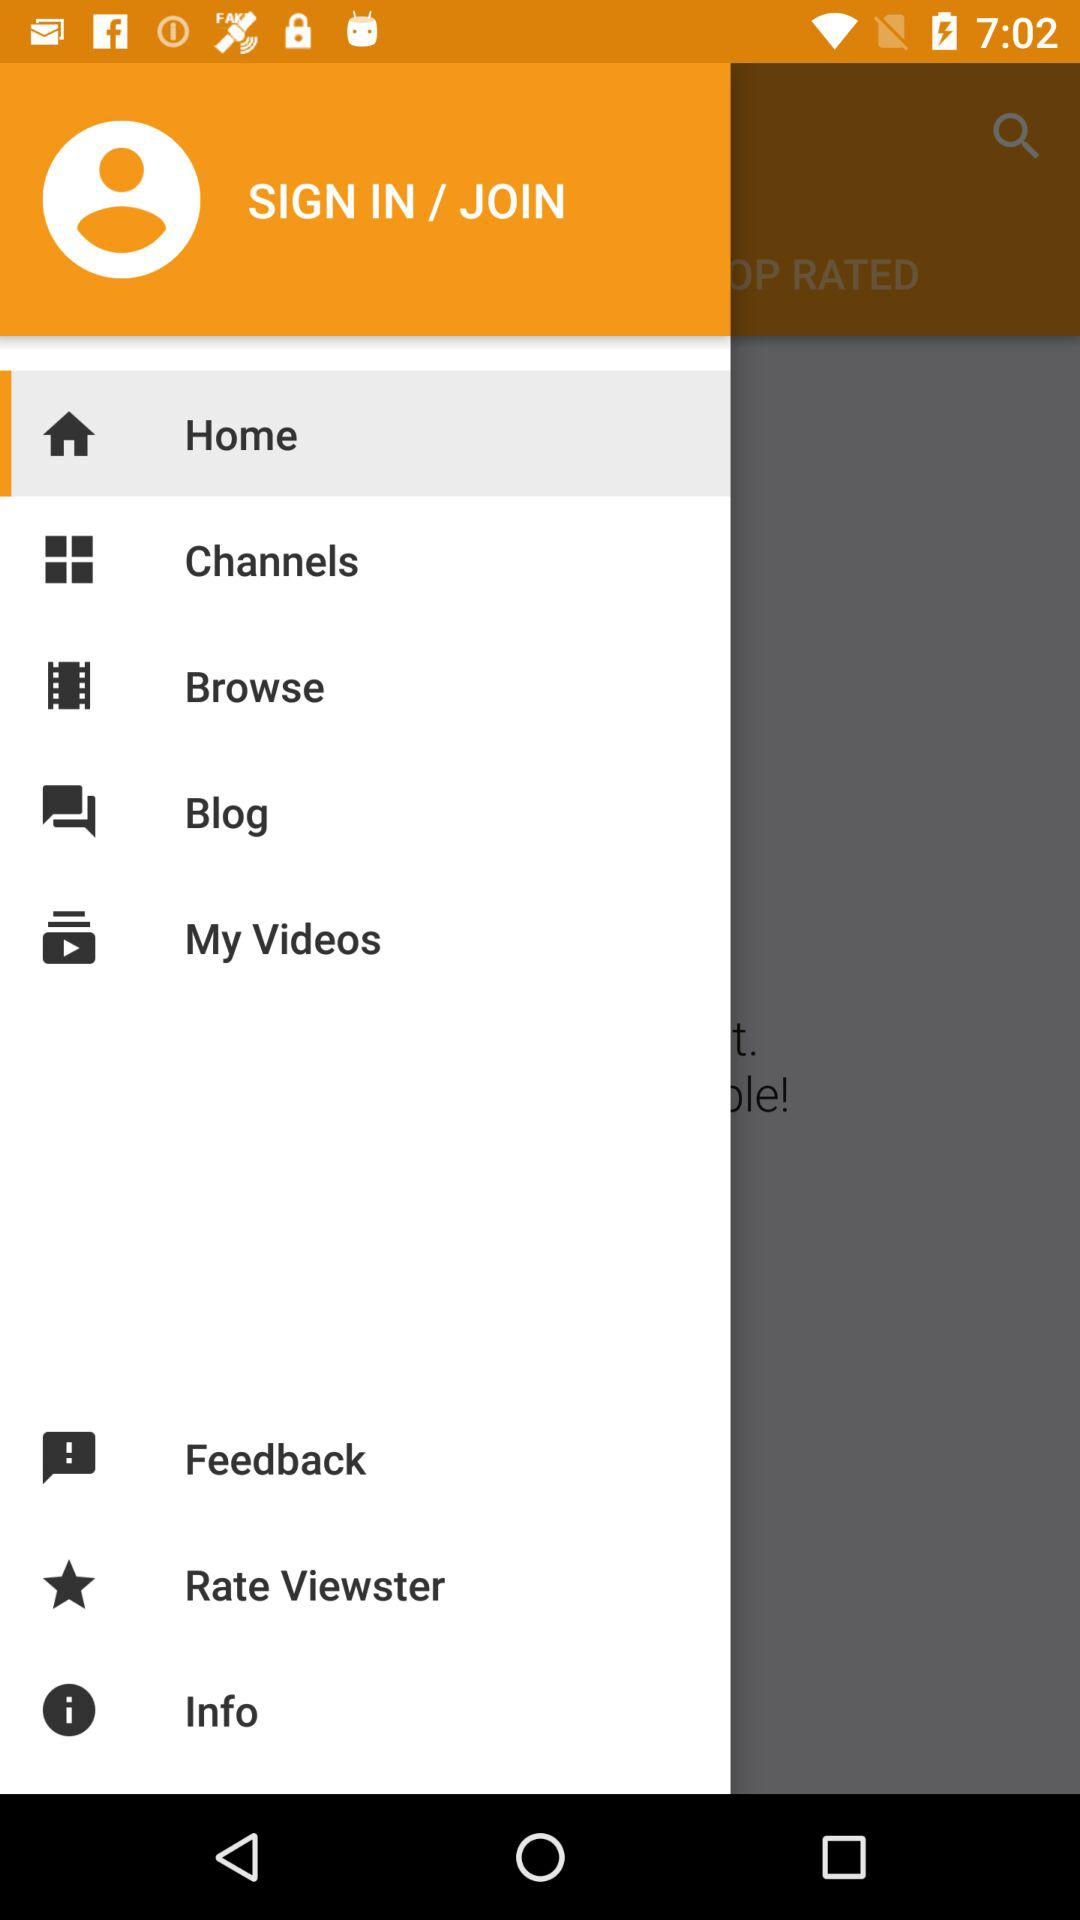Which is the selected tab? The selected tab is "Home". 